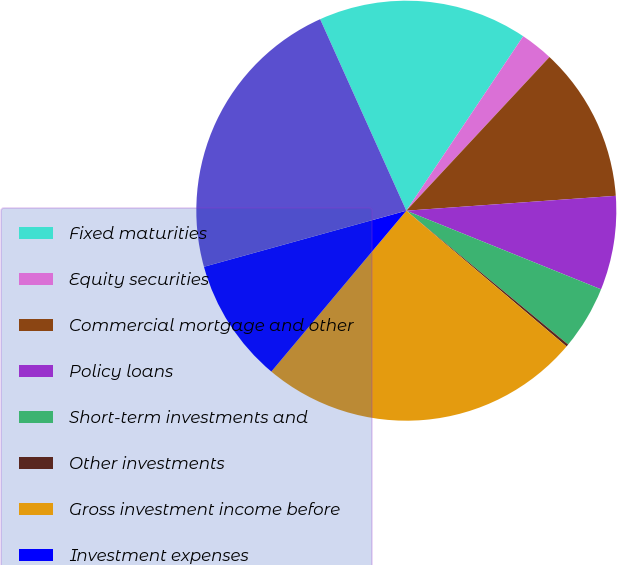Convert chart. <chart><loc_0><loc_0><loc_500><loc_500><pie_chart><fcel>Fixed maturities<fcel>Equity securities<fcel>Commercial mortgage and other<fcel>Policy loans<fcel>Short-term investments and<fcel>Other investments<fcel>Gross investment income before<fcel>Investment expenses<fcel>Investment income after<nl><fcel>16.13%<fcel>2.54%<fcel>11.94%<fcel>7.24%<fcel>4.89%<fcel>0.19%<fcel>24.93%<fcel>9.59%<fcel>22.58%<nl></chart> 